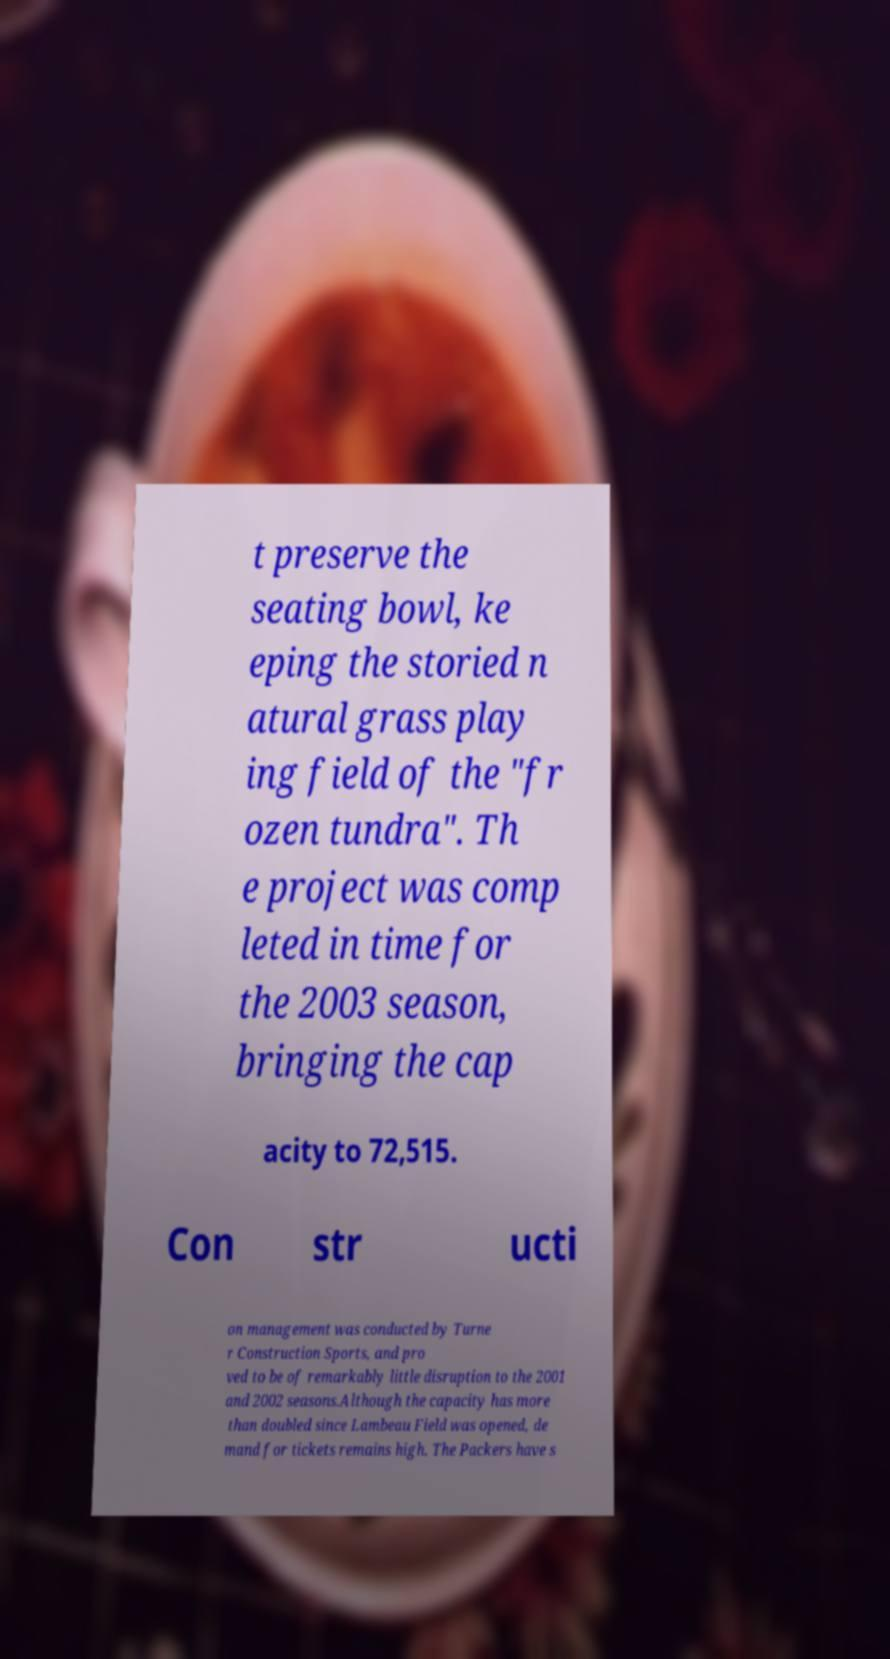What messages or text are displayed in this image? I need them in a readable, typed format. t preserve the seating bowl, ke eping the storied n atural grass play ing field of the "fr ozen tundra". Th e project was comp leted in time for the 2003 season, bringing the cap acity to 72,515. Con str ucti on management was conducted by Turne r Construction Sports, and pro ved to be of remarkably little disruption to the 2001 and 2002 seasons.Although the capacity has more than doubled since Lambeau Field was opened, de mand for tickets remains high. The Packers have s 